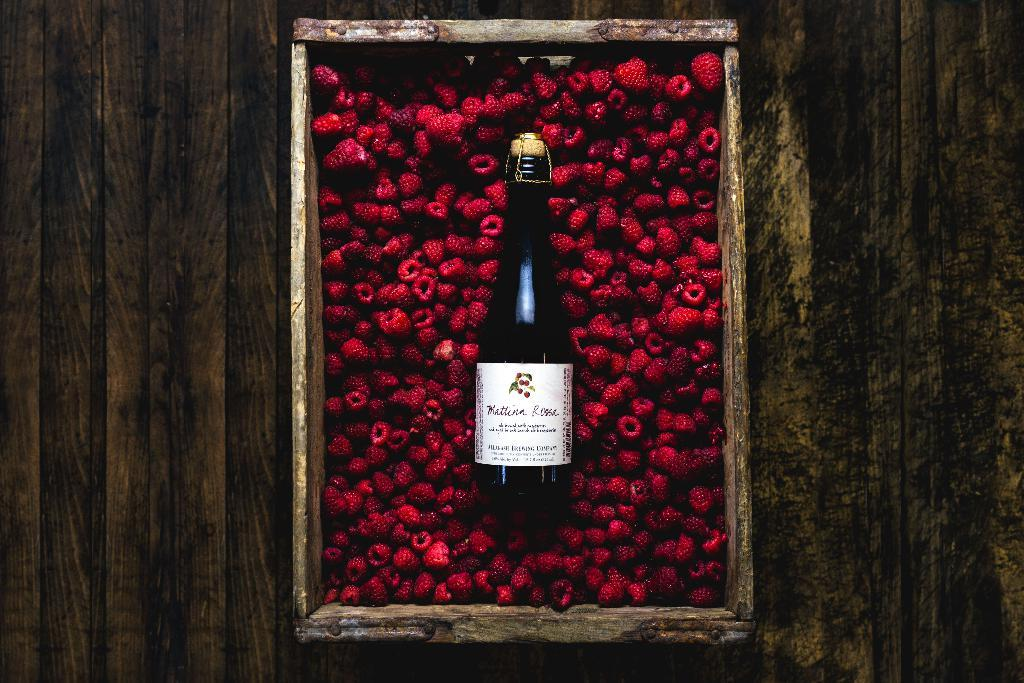<image>
Share a concise interpretation of the image provided. A bottle of Mattina Rossa is laying in an open crate full of raspberries. 